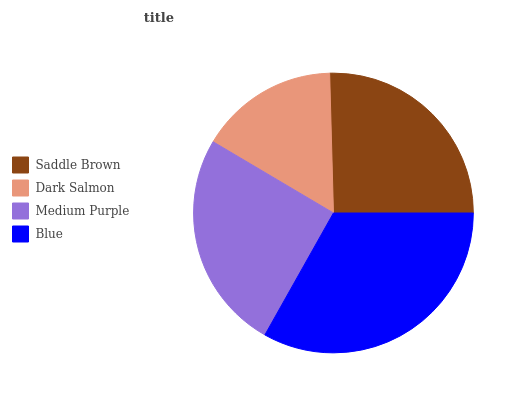Is Dark Salmon the minimum?
Answer yes or no. Yes. Is Blue the maximum?
Answer yes or no. Yes. Is Medium Purple the minimum?
Answer yes or no. No. Is Medium Purple the maximum?
Answer yes or no. No. Is Medium Purple greater than Dark Salmon?
Answer yes or no. Yes. Is Dark Salmon less than Medium Purple?
Answer yes or no. Yes. Is Dark Salmon greater than Medium Purple?
Answer yes or no. No. Is Medium Purple less than Dark Salmon?
Answer yes or no. No. Is Saddle Brown the high median?
Answer yes or no. Yes. Is Medium Purple the low median?
Answer yes or no. Yes. Is Dark Salmon the high median?
Answer yes or no. No. Is Saddle Brown the low median?
Answer yes or no. No. 